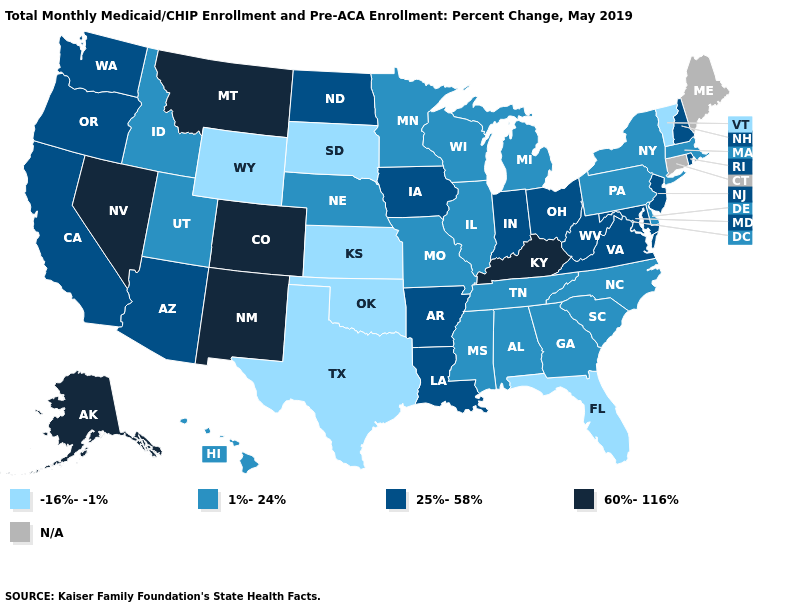What is the value of Washington?
Write a very short answer. 25%-58%. Among the states that border Michigan , which have the highest value?
Be succinct. Indiana, Ohio. Name the states that have a value in the range -16%--1%?
Short answer required. Florida, Kansas, Oklahoma, South Dakota, Texas, Vermont, Wyoming. Does the first symbol in the legend represent the smallest category?
Give a very brief answer. Yes. Among the states that border West Virginia , which have the lowest value?
Answer briefly. Pennsylvania. What is the lowest value in states that border Mississippi?
Short answer required. 1%-24%. Among the states that border Maryland , which have the highest value?
Quick response, please. Virginia, West Virginia. What is the highest value in the USA?
Quick response, please. 60%-116%. Is the legend a continuous bar?
Keep it brief. No. Does the first symbol in the legend represent the smallest category?
Concise answer only. Yes. Among the states that border Utah , which have the highest value?
Answer briefly. Colorado, Nevada, New Mexico. What is the highest value in states that border Kentucky?
Concise answer only. 25%-58%. What is the value of Iowa?
Write a very short answer. 25%-58%. What is the highest value in the MidWest ?
Answer briefly. 25%-58%. 